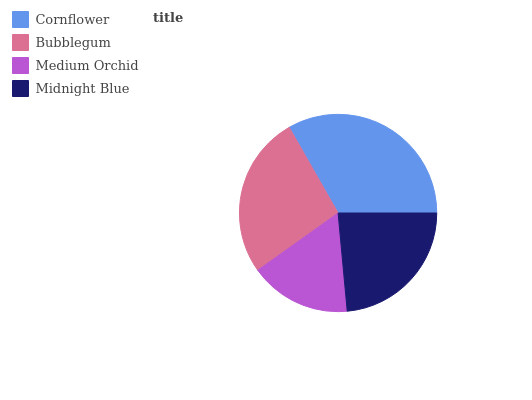Is Medium Orchid the minimum?
Answer yes or no. Yes. Is Cornflower the maximum?
Answer yes or no. Yes. Is Bubblegum the minimum?
Answer yes or no. No. Is Bubblegum the maximum?
Answer yes or no. No. Is Cornflower greater than Bubblegum?
Answer yes or no. Yes. Is Bubblegum less than Cornflower?
Answer yes or no. Yes. Is Bubblegum greater than Cornflower?
Answer yes or no. No. Is Cornflower less than Bubblegum?
Answer yes or no. No. Is Bubblegum the high median?
Answer yes or no. Yes. Is Midnight Blue the low median?
Answer yes or no. Yes. Is Cornflower the high median?
Answer yes or no. No. Is Medium Orchid the low median?
Answer yes or no. No. 